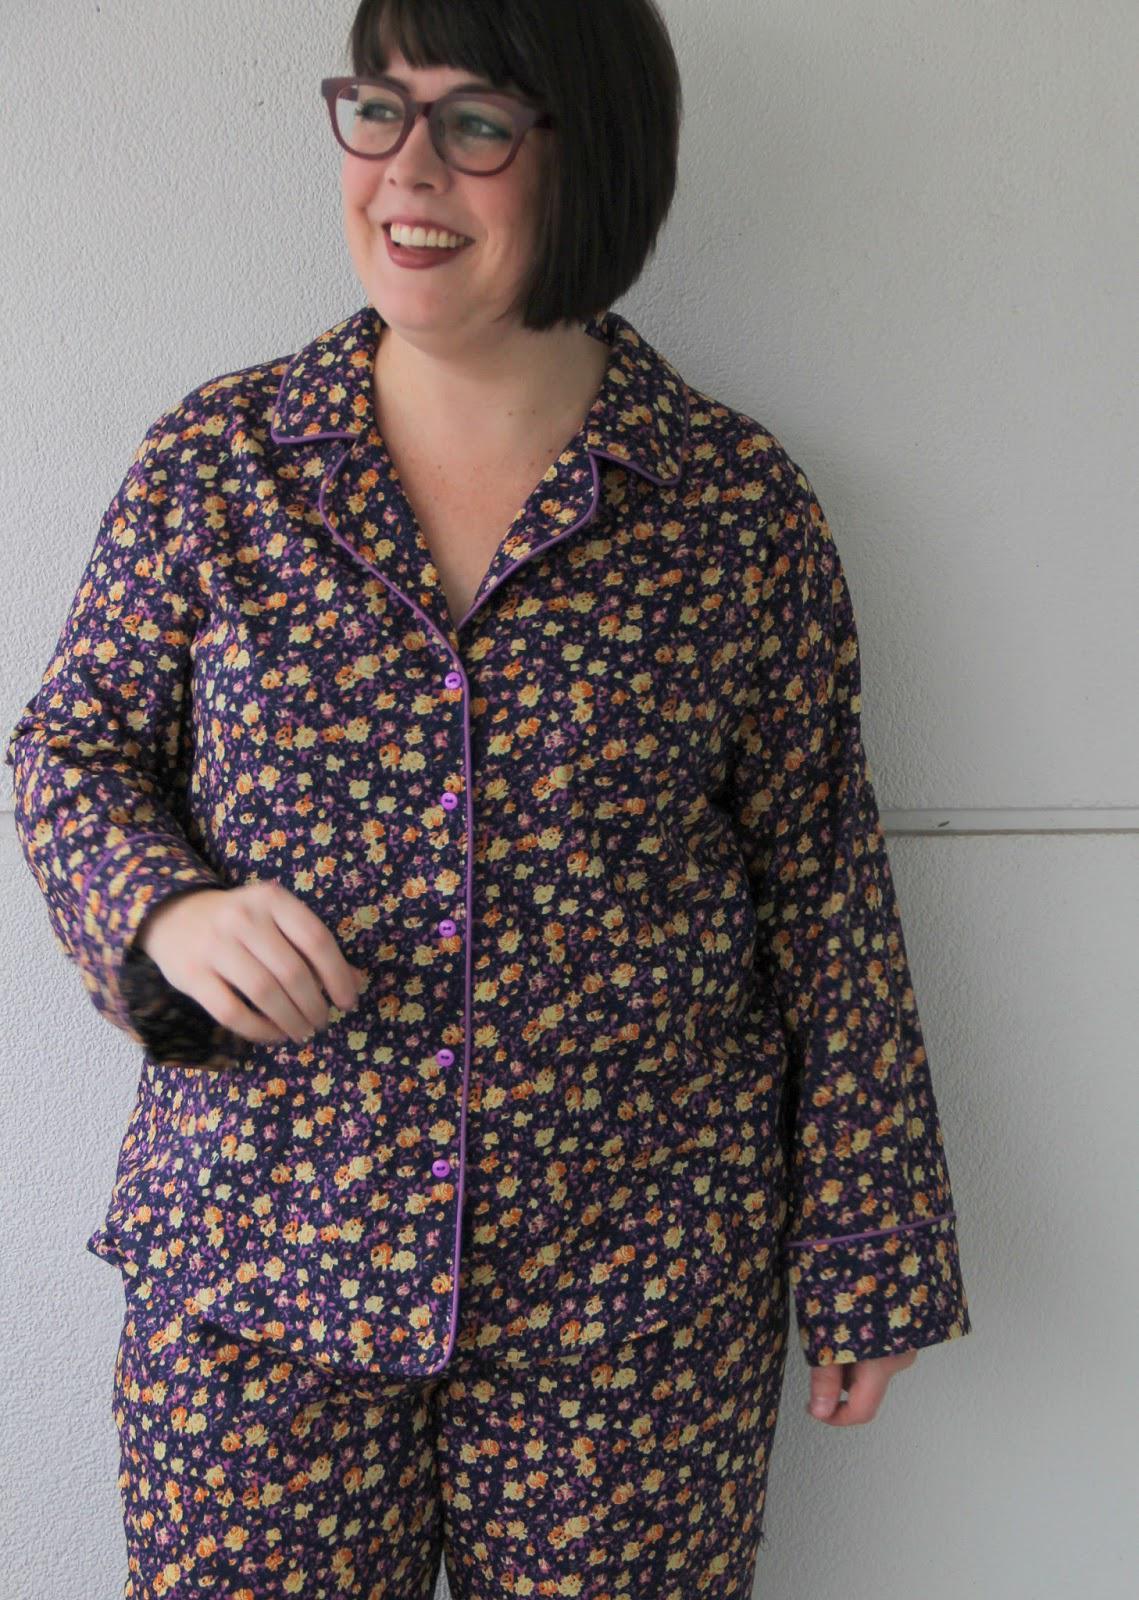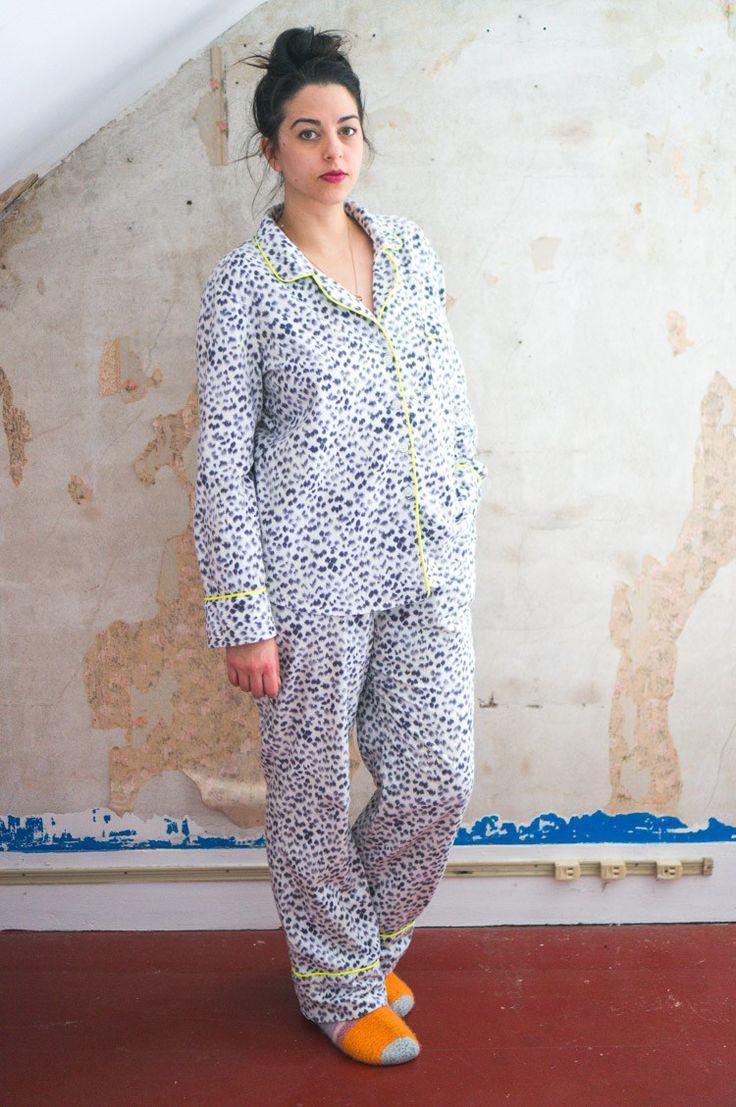The first image is the image on the left, the second image is the image on the right. Given the left and right images, does the statement "The woman in one of the image is wearing a pair of glasses." hold true? Answer yes or no. Yes. 